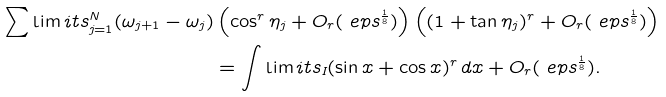Convert formula to latex. <formula><loc_0><loc_0><loc_500><loc_500>\sum \lim i t s _ { j = 1 } ^ { N } ( \omega _ { j + 1 } - \omega _ { j } ) & \left ( \cos ^ { r } \eta _ { j } + O _ { r } ( \ e p s ^ { \frac { 1 } { 8 } } ) \right ) \left ( ( 1 + \tan \eta _ { j } ) ^ { r } + O _ { r } ( \ e p s ^ { \frac { 1 } { 8 } } ) \right ) \\ & = \int \lim i t s _ { I } ( \sin x + \cos x ) ^ { r } \, d x + O _ { r } ( \ e p s ^ { \frac { 1 } { 8 } } ) .</formula> 